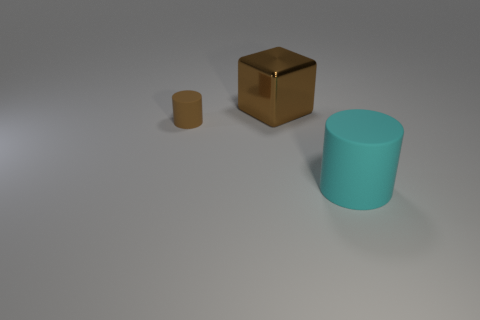Is there anything else that is the same size as the brown matte object?
Make the answer very short. No. Are there any other things that have the same material as the large brown thing?
Ensure brevity in your answer.  No. There is a tiny thing that is the same color as the large cube; what is it made of?
Your answer should be compact. Rubber. How many other things are there of the same color as the small object?
Offer a terse response. 1. Are the large thing that is on the left side of the large cyan cylinder and the cylinder on the left side of the large cyan cylinder made of the same material?
Offer a terse response. No. How many objects are large objects in front of the large metallic thing or big matte cylinders?
Make the answer very short. 1. What number of objects are either cylinders or matte things that are to the right of the brown rubber cylinder?
Ensure brevity in your answer.  2. How many yellow rubber cubes are the same size as the cyan rubber thing?
Offer a terse response. 0. Is the number of shiny blocks that are right of the cyan rubber cylinder less than the number of large cyan rubber things that are behind the tiny brown cylinder?
Provide a short and direct response. No. How many rubber things are large blue cubes or large cyan things?
Provide a short and direct response. 1. 